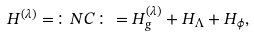Convert formula to latex. <formula><loc_0><loc_0><loc_500><loc_500>H ^ { ( \lambda ) } = \colon N C \colon = H ^ { ( \lambda ) } _ { g } + H _ { \Lambda } + H _ { \phi } ,</formula> 